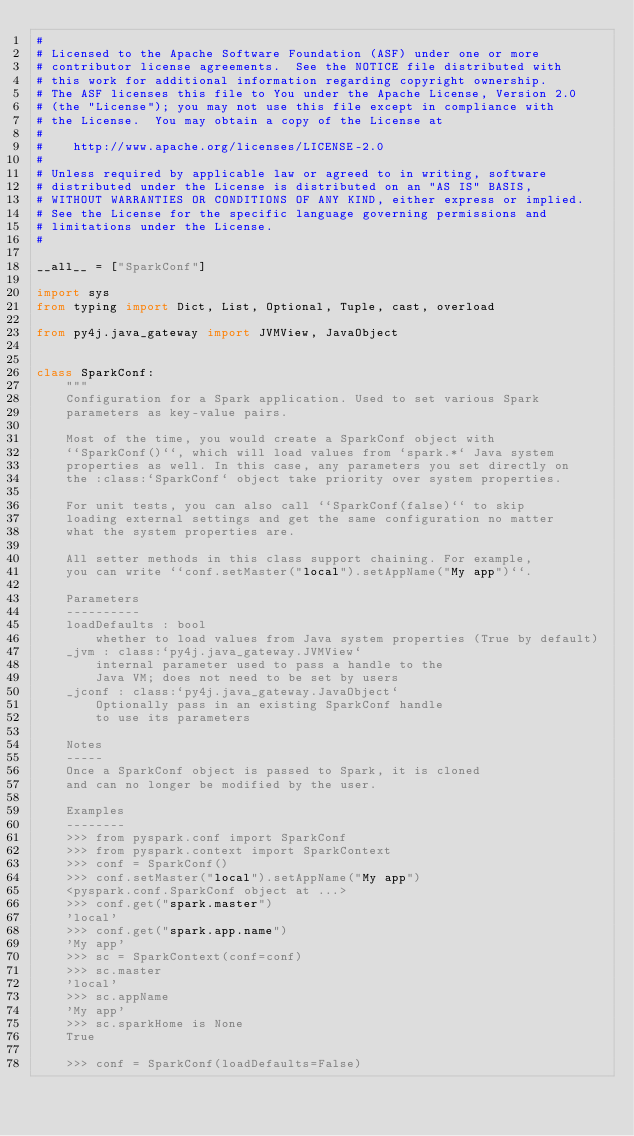Convert code to text. <code><loc_0><loc_0><loc_500><loc_500><_Python_>#
# Licensed to the Apache Software Foundation (ASF) under one or more
# contributor license agreements.  See the NOTICE file distributed with
# this work for additional information regarding copyright ownership.
# The ASF licenses this file to You under the Apache License, Version 2.0
# (the "License"); you may not use this file except in compliance with
# the License.  You may obtain a copy of the License at
#
#    http://www.apache.org/licenses/LICENSE-2.0
#
# Unless required by applicable law or agreed to in writing, software
# distributed under the License is distributed on an "AS IS" BASIS,
# WITHOUT WARRANTIES OR CONDITIONS OF ANY KIND, either express or implied.
# See the License for the specific language governing permissions and
# limitations under the License.
#

__all__ = ["SparkConf"]

import sys
from typing import Dict, List, Optional, Tuple, cast, overload

from py4j.java_gateway import JVMView, JavaObject


class SparkConf:
    """
    Configuration for a Spark application. Used to set various Spark
    parameters as key-value pairs.

    Most of the time, you would create a SparkConf object with
    ``SparkConf()``, which will load values from `spark.*` Java system
    properties as well. In this case, any parameters you set directly on
    the :class:`SparkConf` object take priority over system properties.

    For unit tests, you can also call ``SparkConf(false)`` to skip
    loading external settings and get the same configuration no matter
    what the system properties are.

    All setter methods in this class support chaining. For example,
    you can write ``conf.setMaster("local").setAppName("My app")``.

    Parameters
    ----------
    loadDefaults : bool
        whether to load values from Java system properties (True by default)
    _jvm : class:`py4j.java_gateway.JVMView`
        internal parameter used to pass a handle to the
        Java VM; does not need to be set by users
    _jconf : class:`py4j.java_gateway.JavaObject`
        Optionally pass in an existing SparkConf handle
        to use its parameters

    Notes
    -----
    Once a SparkConf object is passed to Spark, it is cloned
    and can no longer be modified by the user.

    Examples
    --------
    >>> from pyspark.conf import SparkConf
    >>> from pyspark.context import SparkContext
    >>> conf = SparkConf()
    >>> conf.setMaster("local").setAppName("My app")
    <pyspark.conf.SparkConf object at ...>
    >>> conf.get("spark.master")
    'local'
    >>> conf.get("spark.app.name")
    'My app'
    >>> sc = SparkContext(conf=conf)
    >>> sc.master
    'local'
    >>> sc.appName
    'My app'
    >>> sc.sparkHome is None
    True

    >>> conf = SparkConf(loadDefaults=False)</code> 